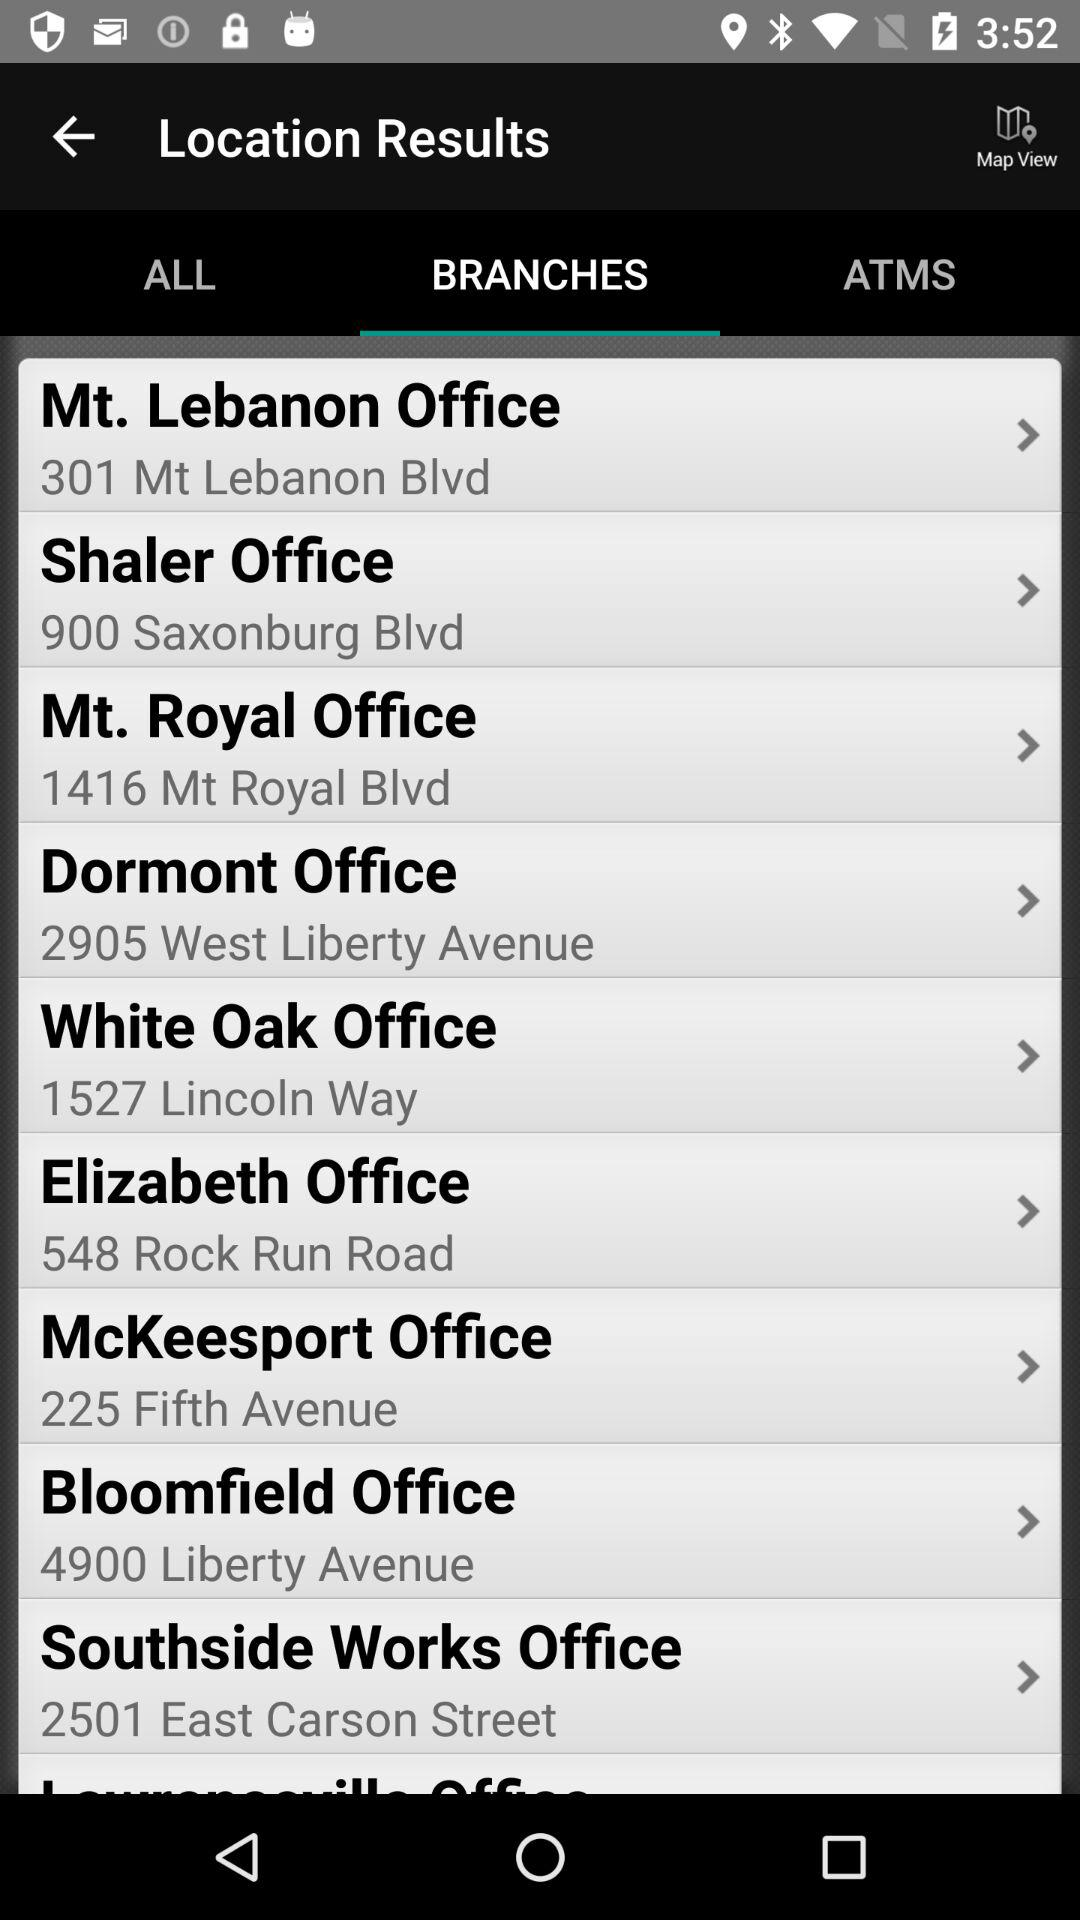Which tab is selected? The selected tab is "BRANCHES". 